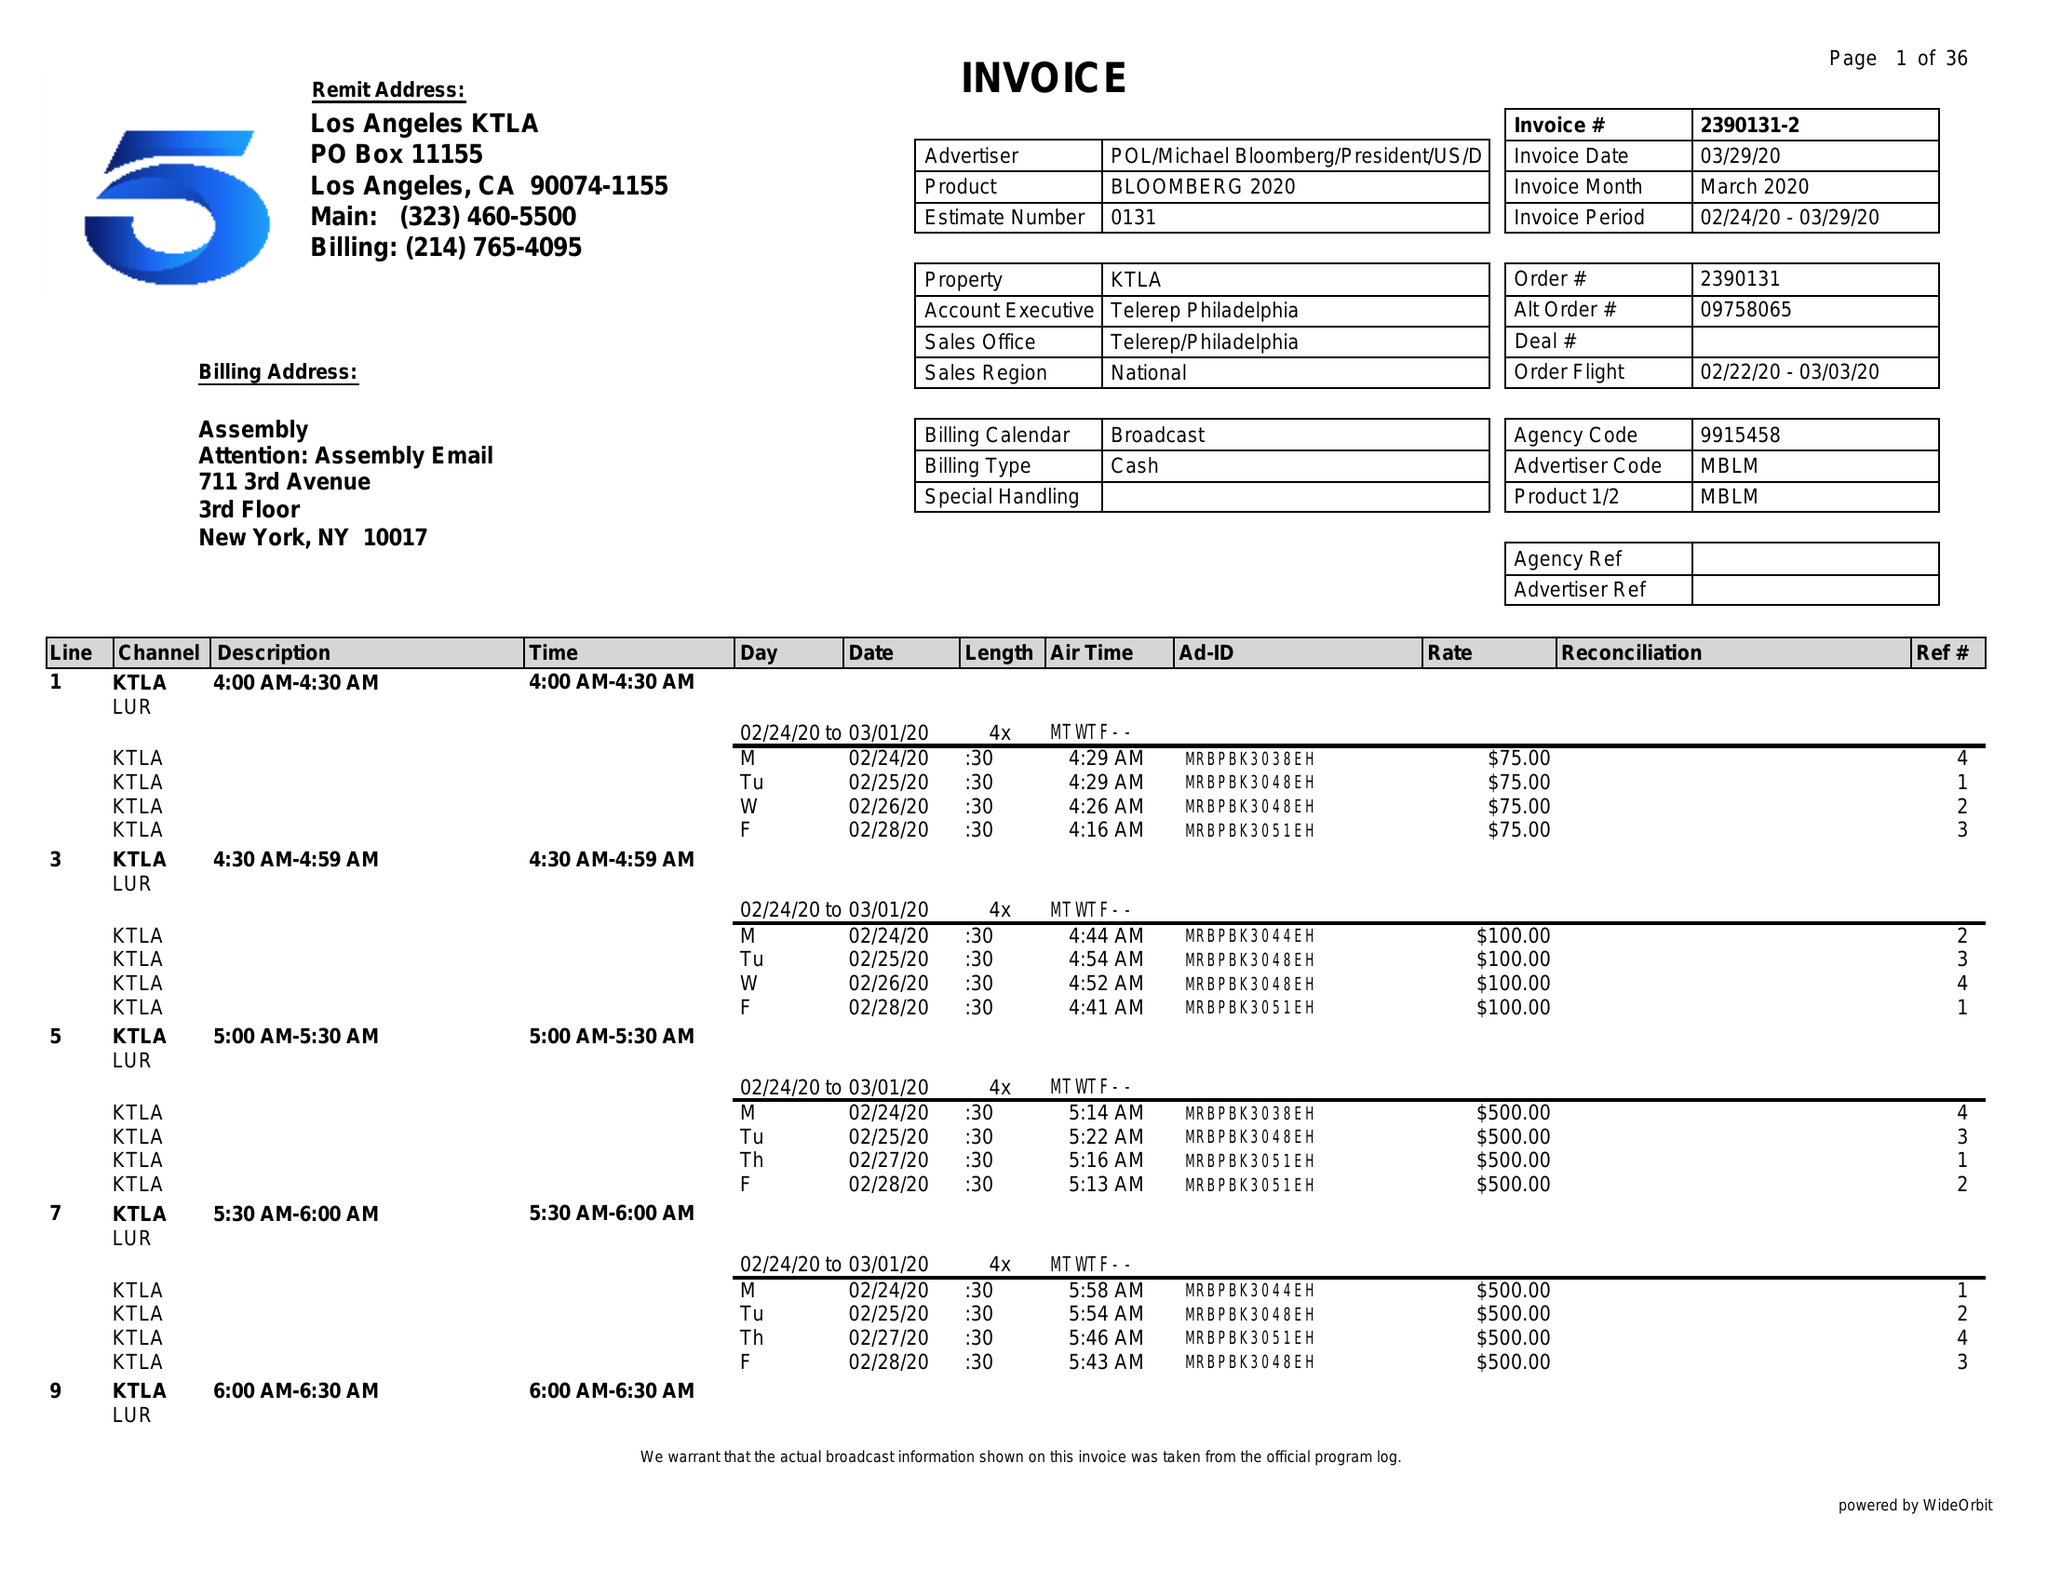What is the value for the flight_to?
Answer the question using a single word or phrase. 03/03/20 